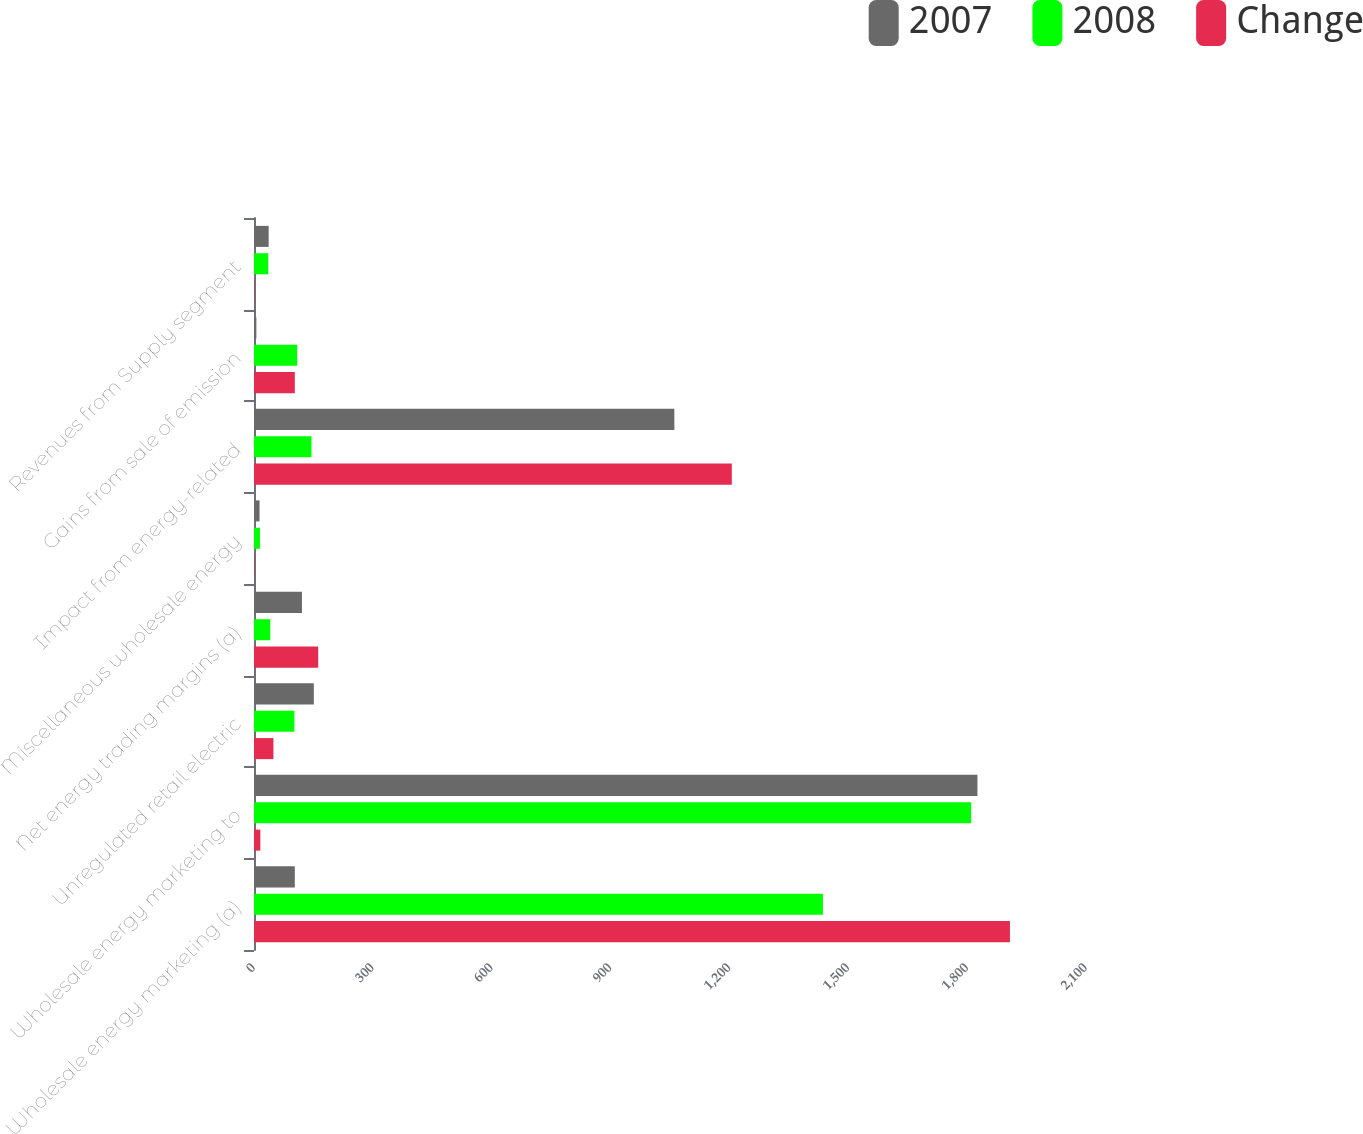<chart> <loc_0><loc_0><loc_500><loc_500><stacked_bar_chart><ecel><fcel>Wholesale energy marketing (a)<fcel>Wholesale energy marketing to<fcel>Unregulated retail electric<fcel>Net energy trading margins (a)<fcel>Miscellaneous wholesale energy<fcel>Impact from energy-related<fcel>Gains from sale of emission<fcel>Revenues from Supply segment<nl><fcel>2007<fcel>103<fcel>1826<fcel>151<fcel>121<fcel>14<fcel>1061<fcel>6<fcel>37<nl><fcel>2008<fcel>1436<fcel>1810<fcel>102<fcel>41<fcel>15<fcel>145<fcel>109<fcel>36<nl><fcel>Change<fcel>1908<fcel>16<fcel>49<fcel>162<fcel>1<fcel>1206<fcel>103<fcel>1<nl></chart> 